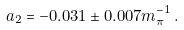<formula> <loc_0><loc_0><loc_500><loc_500>a _ { 2 } = - 0 . 0 3 1 \pm 0 . 0 0 7 m _ { \pi } ^ { - 1 } \, .</formula> 